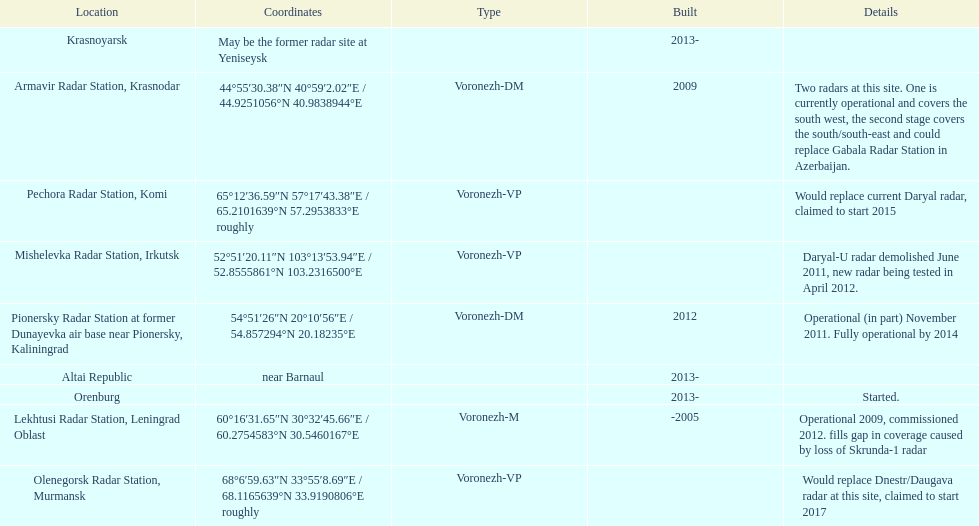What is the only radar that will start in 2015? Pechora Radar Station, Komi. Could you parse the entire table as a dict? {'header': ['Location', 'Coordinates', 'Type', 'Built', 'Details'], 'rows': [['Krasnoyarsk', 'May be the former radar site at Yeniseysk', '', '2013-', ''], ['Armavir Radar Station, Krasnodar', '44°55′30.38″N 40°59′2.02″E\ufeff / \ufeff44.9251056°N 40.9838944°E', 'Voronezh-DM', '2009', 'Two radars at this site. One is currently operational and covers the south west, the second stage covers the south/south-east and could replace Gabala Radar Station in Azerbaijan.'], ['Pechora Radar Station, Komi', '65°12′36.59″N 57°17′43.38″E\ufeff / \ufeff65.2101639°N 57.2953833°E roughly', 'Voronezh-VP', '', 'Would replace current Daryal radar, claimed to start 2015'], ['Mishelevka Radar Station, Irkutsk', '52°51′20.11″N 103°13′53.94″E\ufeff / \ufeff52.8555861°N 103.2316500°E', 'Voronezh-VP', '', 'Daryal-U radar demolished June 2011, new radar being tested in April 2012.'], ['Pionersky Radar Station at former Dunayevka air base near Pionersky, Kaliningrad', '54°51′26″N 20°10′56″E\ufeff / \ufeff54.857294°N 20.18235°E', 'Voronezh-DM', '2012', 'Operational (in part) November 2011. Fully operational by 2014'], ['Altai Republic', 'near Barnaul', '', '2013-', ''], ['Orenburg', '', '', '2013-', 'Started.'], ['Lekhtusi Radar Station, Leningrad Oblast', '60°16′31.65″N 30°32′45.66″E\ufeff / \ufeff60.2754583°N 30.5460167°E', 'Voronezh-M', '-2005', 'Operational 2009, commissioned 2012. fills gap in coverage caused by loss of Skrunda-1 radar'], ['Olenegorsk Radar Station, Murmansk', '68°6′59.63″N 33°55′8.69″E\ufeff / \ufeff68.1165639°N 33.9190806°E roughly', 'Voronezh-VP', '', 'Would replace Dnestr/Daugava radar at this site, claimed to start 2017']]} 